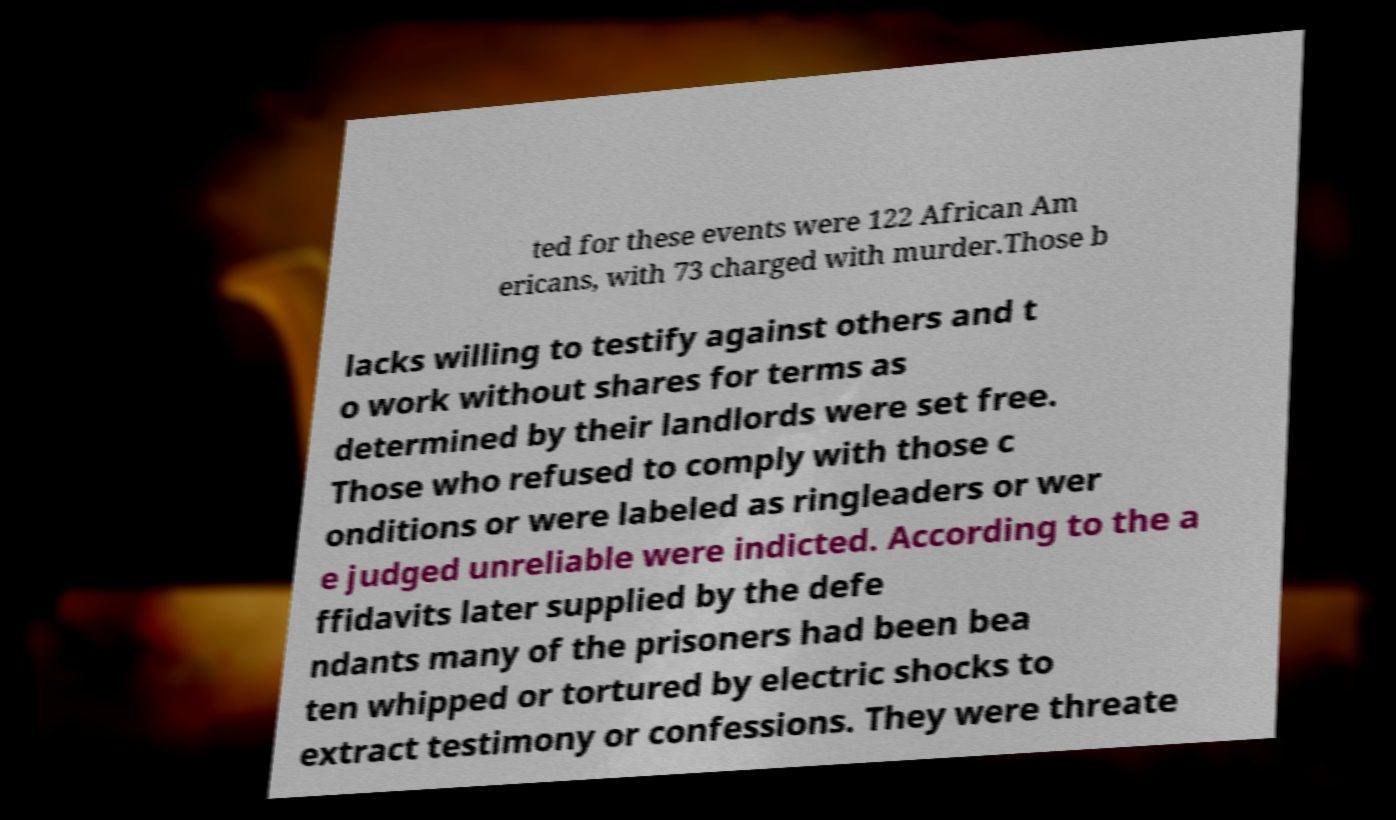Could you extract and type out the text from this image? ted for these events were 122 African Am ericans, with 73 charged with murder.Those b lacks willing to testify against others and t o work without shares for terms as determined by their landlords were set free. Those who refused to comply with those c onditions or were labeled as ringleaders or wer e judged unreliable were indicted. According to the a ffidavits later supplied by the defe ndants many of the prisoners had been bea ten whipped or tortured by electric shocks to extract testimony or confessions. They were threate 